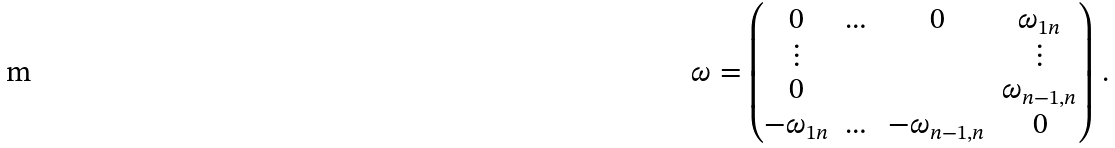<formula> <loc_0><loc_0><loc_500><loc_500>\omega = \begin{pmatrix} 0 & \dots & 0 & \omega _ { 1 n } \\ \vdots & & & \vdots \\ 0 & & & \omega _ { n - 1 , n } \\ - \omega _ { 1 n } & \dots & - \omega _ { n - 1 , n } & 0 \end{pmatrix} \, .</formula> 